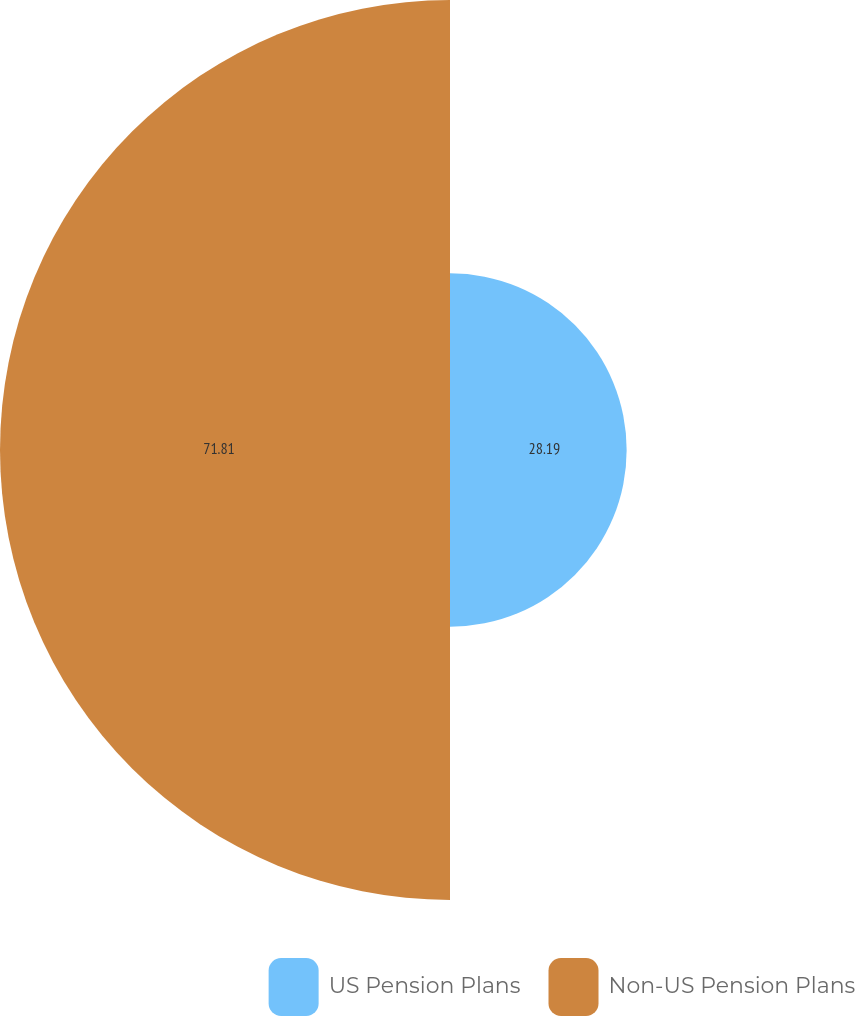<chart> <loc_0><loc_0><loc_500><loc_500><pie_chart><fcel>US Pension Plans<fcel>Non-US Pension Plans<nl><fcel>28.19%<fcel>71.81%<nl></chart> 